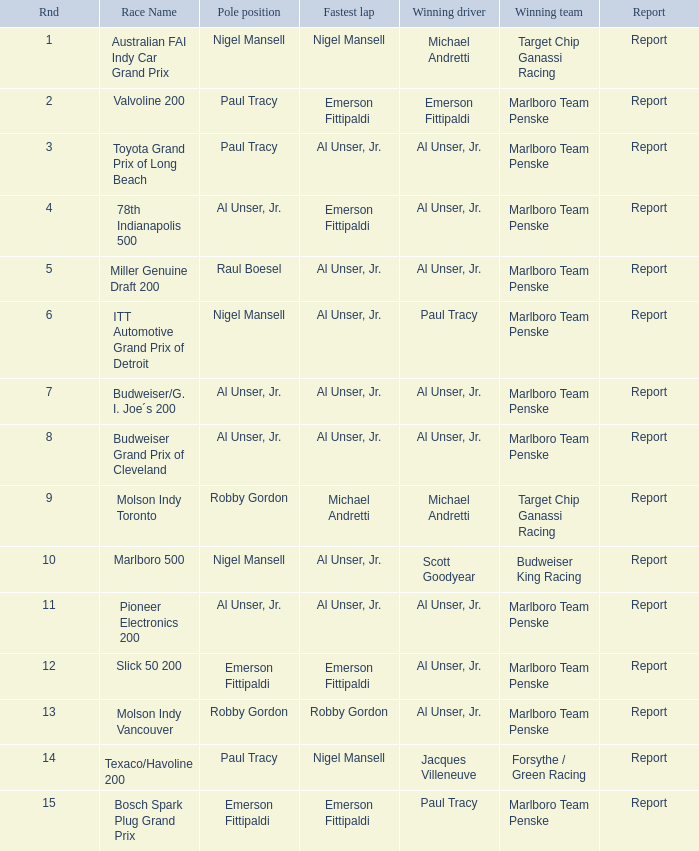Who did the fastest lap in the race won by Paul Tracy, with Emerson Fittipaldi at the pole position? Emerson Fittipaldi. 